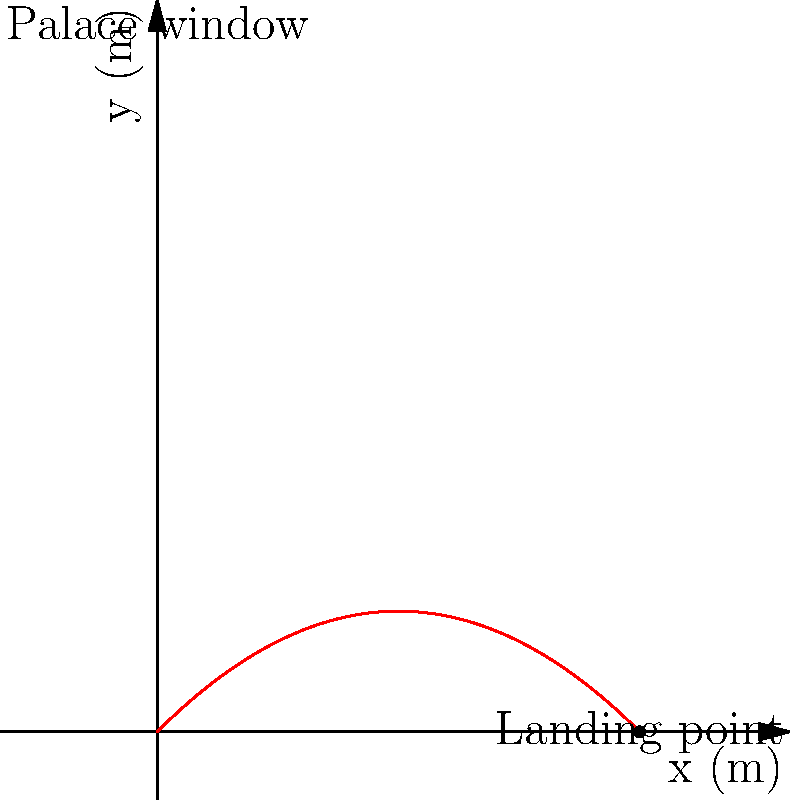A confidential document is thrown from a palace window 15 meters above the ground with an initial velocity of 10 m/s at an angle of 45° to the horizontal. Assuming no air resistance, at what horizontal distance from the base of the palace wall will the document land? To solve this problem, we'll use the equations of projectile motion:

1) Horizontal motion: $x = v_0 \cos(\theta) t$
2) Vertical motion: $y = v_0 \sin(\theta) t - \frac{1}{2}gt^2$

Given:
- Initial height $h = 15$ m
- Initial velocity $v_0 = 10$ m/s
- Angle $\theta = 45°$
- Gravitational acceleration $g = 9.8$ m/s²

Steps:
1) First, we need to find the time it takes for the document to reach the ground. We can use the vertical motion equation:

   $0 = h + v_0 \sin(\theta) t - \frac{1}{2}gt^2$

2) Substituting the values:

   $0 = 15 + 10 \sin(45°) t - \frac{1}{2}(9.8)t^2$

3) Simplify:

   $0 = 15 + 7.07t - 4.9t^2$

4) This is a quadratic equation. Solve for t using the quadratic formula:

   $t = \frac{-b \pm \sqrt{b^2 - 4ac}}{2a}$

   Where $a = -4.9$, $b = 7.07$, and $c = 15$

5) Solving this gives us two solutions. We take the positive one:

   $t \approx 2.04$ seconds

6) Now we can use the horizontal motion equation to find the distance:

   $x = v_0 \cos(\theta) t$

7) Substituting the values:

   $x = 10 \cos(45°) (2.04) \approx 14.42$ m

Therefore, the document will land approximately 14.42 meters from the base of the palace wall.
Answer: 14.42 meters 